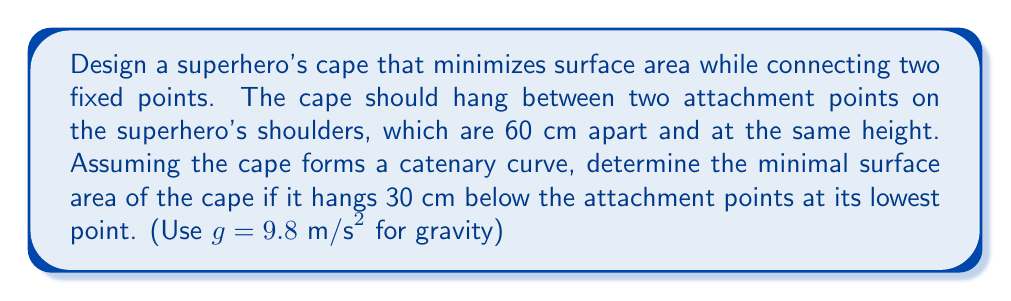Teach me how to tackle this problem. To solve this problem, we'll use the principles of minimal surfaces and the catenary curve. The steps are as follows:

1) The catenary curve is described by the equation:

   $$y = a \cosh(\frac{x}{a})$$

   where $a$ is a constant that determines the shape of the curve.

2) Given that the lowest point of the cape is 30 cm below the attachment points, we can determine $a$:

   $$30 = a (\cosh(\frac{30}{a}) - 1)$$

3) This equation can be solved numerically to find $a \approx 39.24$ cm.

4) The surface area of a surface of revolution is given by:

   $$A = 2\pi \int_0^L y \sqrt{1 + (\frac{dy}{dx})^2} dx$$

   where $L$ is half the distance between the attachment points (30 cm).

5) For a catenary curve, $\frac{dy}{dx} = \sinh(\frac{x}{a})$, so our integral becomes:

   $$A = 2\pi \int_0^{30} a \cosh(\frac{x}{a}) \sqrt{1 + \sinh^2(\frac{x}{a})} dx$$

6) This can be simplified to:

   $$A = 2\pi a^2 [\sinh(\frac{x}{a})]_0^{30}$$

7) Evaluating this:

   $$A = 2\pi (39.24)^2 [\sinh(\frac{30}{39.24}) - \sinh(0)]$$

8) Calculating this gives us:

   $$A \approx 5,944 \text{ cm}^2$$

[asy]
import graph;
size(200,100);
real a = 39.24;
real f(real x) {return a*cosh(x/a)-a;}
draw(graph(f,-30,30));
draw((-30,0)--(30,0),dashed);
label("60 cm",(-30,-5),(1,0));
label("30 cm",(0,-15),E);
dot((-30,0));
dot((30,0));
[/asy]
Answer: $5,944 \text{ cm}^2$ 